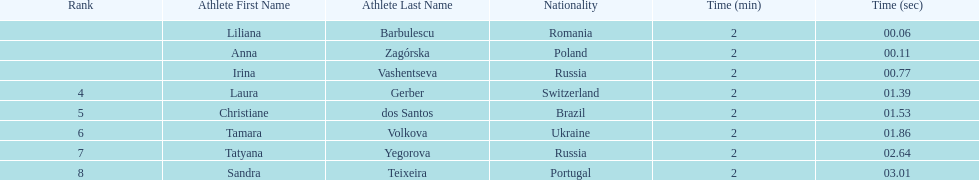What is the name of the top finalist of this semifinals heat? Liliana Barbulescu. 